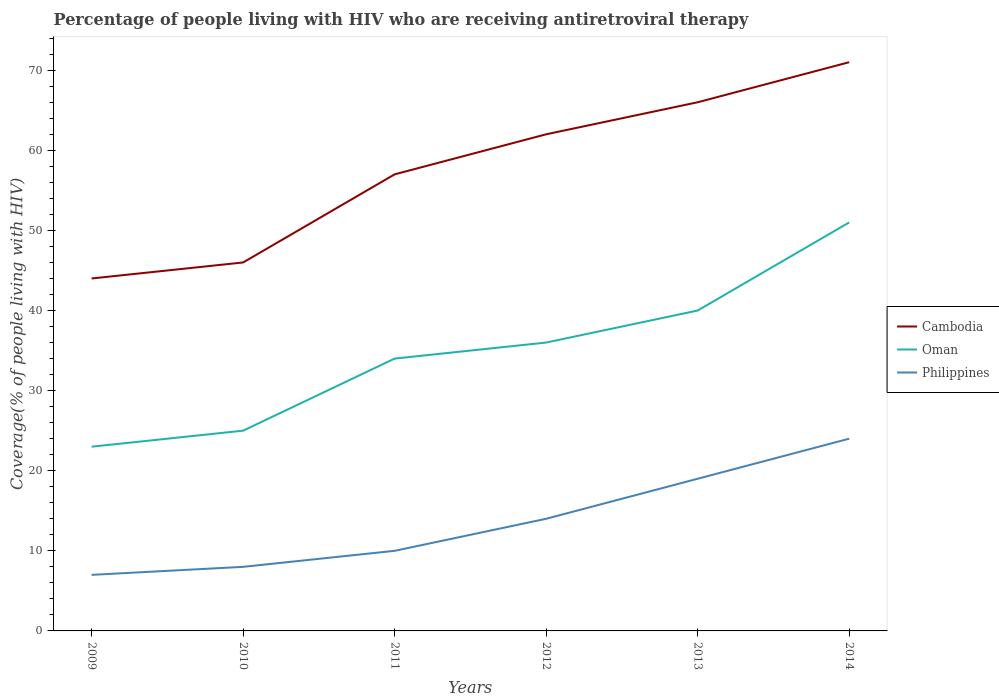How many different coloured lines are there?
Make the answer very short. 3. Does the line corresponding to Oman intersect with the line corresponding to Philippines?
Offer a terse response. No. Across all years, what is the maximum percentage of the HIV infected people who are receiving antiretroviral therapy in Philippines?
Make the answer very short. 7. What is the total percentage of the HIV infected people who are receiving antiretroviral therapy in Oman in the graph?
Make the answer very short. -17. What is the difference between the highest and the second highest percentage of the HIV infected people who are receiving antiretroviral therapy in Cambodia?
Offer a terse response. 27. Is the percentage of the HIV infected people who are receiving antiretroviral therapy in Philippines strictly greater than the percentage of the HIV infected people who are receiving antiretroviral therapy in Oman over the years?
Make the answer very short. Yes. How many years are there in the graph?
Keep it short and to the point. 6. Does the graph contain any zero values?
Your answer should be very brief. No. How many legend labels are there?
Provide a succinct answer. 3. How are the legend labels stacked?
Give a very brief answer. Vertical. What is the title of the graph?
Offer a terse response. Percentage of people living with HIV who are receiving antiretroviral therapy. What is the label or title of the X-axis?
Ensure brevity in your answer.  Years. What is the label or title of the Y-axis?
Offer a very short reply. Coverage(% of people living with HIV). What is the Coverage(% of people living with HIV) in Cambodia in 2009?
Give a very brief answer. 44. What is the Coverage(% of people living with HIV) in Oman in 2009?
Offer a terse response. 23. What is the Coverage(% of people living with HIV) of Philippines in 2010?
Offer a terse response. 8. What is the Coverage(% of people living with HIV) of Cambodia in 2011?
Keep it short and to the point. 57. What is the Coverage(% of people living with HIV) in Philippines in 2011?
Give a very brief answer. 10. What is the Coverage(% of people living with HIV) of Cambodia in 2013?
Offer a very short reply. 66. What is the Coverage(% of people living with HIV) of Philippines in 2013?
Give a very brief answer. 19. What is the Coverage(% of people living with HIV) in Cambodia in 2014?
Your answer should be compact. 71. Across all years, what is the maximum Coverage(% of people living with HIV) in Cambodia?
Keep it short and to the point. 71. Across all years, what is the maximum Coverage(% of people living with HIV) of Philippines?
Provide a short and direct response. 24. Across all years, what is the minimum Coverage(% of people living with HIV) in Philippines?
Your response must be concise. 7. What is the total Coverage(% of people living with HIV) in Cambodia in the graph?
Ensure brevity in your answer.  346. What is the total Coverage(% of people living with HIV) in Oman in the graph?
Provide a succinct answer. 209. What is the total Coverage(% of people living with HIV) of Philippines in the graph?
Your answer should be very brief. 82. What is the difference between the Coverage(% of people living with HIV) of Cambodia in 2009 and that in 2011?
Provide a succinct answer. -13. What is the difference between the Coverage(% of people living with HIV) in Oman in 2009 and that in 2011?
Provide a succinct answer. -11. What is the difference between the Coverage(% of people living with HIV) in Philippines in 2009 and that in 2011?
Offer a very short reply. -3. What is the difference between the Coverage(% of people living with HIV) of Philippines in 2009 and that in 2012?
Provide a short and direct response. -7. What is the difference between the Coverage(% of people living with HIV) in Cambodia in 2009 and that in 2013?
Offer a terse response. -22. What is the difference between the Coverage(% of people living with HIV) of Oman in 2009 and that in 2013?
Your answer should be very brief. -17. What is the difference between the Coverage(% of people living with HIV) in Philippines in 2009 and that in 2013?
Offer a terse response. -12. What is the difference between the Coverage(% of people living with HIV) of Oman in 2009 and that in 2014?
Provide a short and direct response. -28. What is the difference between the Coverage(% of people living with HIV) in Philippines in 2009 and that in 2014?
Provide a succinct answer. -17. What is the difference between the Coverage(% of people living with HIV) of Cambodia in 2010 and that in 2011?
Make the answer very short. -11. What is the difference between the Coverage(% of people living with HIV) of Oman in 2010 and that in 2011?
Give a very brief answer. -9. What is the difference between the Coverage(% of people living with HIV) in Philippines in 2010 and that in 2011?
Ensure brevity in your answer.  -2. What is the difference between the Coverage(% of people living with HIV) of Philippines in 2010 and that in 2012?
Your response must be concise. -6. What is the difference between the Coverage(% of people living with HIV) in Cambodia in 2010 and that in 2013?
Provide a short and direct response. -20. What is the difference between the Coverage(% of people living with HIV) of Oman in 2010 and that in 2013?
Offer a very short reply. -15. What is the difference between the Coverage(% of people living with HIV) of Philippines in 2010 and that in 2013?
Offer a very short reply. -11. What is the difference between the Coverage(% of people living with HIV) in Cambodia in 2010 and that in 2014?
Offer a very short reply. -25. What is the difference between the Coverage(% of people living with HIV) in Cambodia in 2011 and that in 2012?
Your answer should be compact. -5. What is the difference between the Coverage(% of people living with HIV) in Oman in 2011 and that in 2012?
Ensure brevity in your answer.  -2. What is the difference between the Coverage(% of people living with HIV) of Philippines in 2011 and that in 2012?
Make the answer very short. -4. What is the difference between the Coverage(% of people living with HIV) in Cambodia in 2011 and that in 2013?
Provide a succinct answer. -9. What is the difference between the Coverage(% of people living with HIV) in Oman in 2011 and that in 2013?
Offer a very short reply. -6. What is the difference between the Coverage(% of people living with HIV) of Philippines in 2011 and that in 2013?
Provide a succinct answer. -9. What is the difference between the Coverage(% of people living with HIV) of Oman in 2011 and that in 2014?
Your answer should be very brief. -17. What is the difference between the Coverage(% of people living with HIV) in Philippines in 2011 and that in 2014?
Your response must be concise. -14. What is the difference between the Coverage(% of people living with HIV) in Oman in 2012 and that in 2013?
Keep it short and to the point. -4. What is the difference between the Coverage(% of people living with HIV) in Oman in 2012 and that in 2014?
Offer a very short reply. -15. What is the difference between the Coverage(% of people living with HIV) of Oman in 2013 and that in 2014?
Your answer should be very brief. -11. What is the difference between the Coverage(% of people living with HIV) of Philippines in 2013 and that in 2014?
Provide a succinct answer. -5. What is the difference between the Coverage(% of people living with HIV) in Cambodia in 2009 and the Coverage(% of people living with HIV) in Oman in 2010?
Your response must be concise. 19. What is the difference between the Coverage(% of people living with HIV) of Oman in 2009 and the Coverage(% of people living with HIV) of Philippines in 2010?
Ensure brevity in your answer.  15. What is the difference between the Coverage(% of people living with HIV) of Cambodia in 2009 and the Coverage(% of people living with HIV) of Oman in 2011?
Offer a terse response. 10. What is the difference between the Coverage(% of people living with HIV) of Oman in 2009 and the Coverage(% of people living with HIV) of Philippines in 2011?
Offer a very short reply. 13. What is the difference between the Coverage(% of people living with HIV) in Cambodia in 2009 and the Coverage(% of people living with HIV) in Philippines in 2012?
Make the answer very short. 30. What is the difference between the Coverage(% of people living with HIV) in Oman in 2009 and the Coverage(% of people living with HIV) in Philippines in 2012?
Give a very brief answer. 9. What is the difference between the Coverage(% of people living with HIV) in Cambodia in 2009 and the Coverage(% of people living with HIV) in Oman in 2013?
Offer a very short reply. 4. What is the difference between the Coverage(% of people living with HIV) of Cambodia in 2009 and the Coverage(% of people living with HIV) of Philippines in 2013?
Keep it short and to the point. 25. What is the difference between the Coverage(% of people living with HIV) in Oman in 2009 and the Coverage(% of people living with HIV) in Philippines in 2014?
Provide a succinct answer. -1. What is the difference between the Coverage(% of people living with HIV) of Oman in 2010 and the Coverage(% of people living with HIV) of Philippines in 2011?
Ensure brevity in your answer.  15. What is the difference between the Coverage(% of people living with HIV) in Cambodia in 2010 and the Coverage(% of people living with HIV) in Oman in 2012?
Your answer should be compact. 10. What is the difference between the Coverage(% of people living with HIV) in Cambodia in 2010 and the Coverage(% of people living with HIV) in Philippines in 2012?
Your response must be concise. 32. What is the difference between the Coverage(% of people living with HIV) in Oman in 2010 and the Coverage(% of people living with HIV) in Philippines in 2012?
Offer a terse response. 11. What is the difference between the Coverage(% of people living with HIV) in Cambodia in 2010 and the Coverage(% of people living with HIV) in Philippines in 2013?
Ensure brevity in your answer.  27. What is the difference between the Coverage(% of people living with HIV) of Cambodia in 2010 and the Coverage(% of people living with HIV) of Oman in 2014?
Give a very brief answer. -5. What is the difference between the Coverage(% of people living with HIV) of Oman in 2010 and the Coverage(% of people living with HIV) of Philippines in 2014?
Your response must be concise. 1. What is the difference between the Coverage(% of people living with HIV) of Cambodia in 2011 and the Coverage(% of people living with HIV) of Oman in 2012?
Keep it short and to the point. 21. What is the difference between the Coverage(% of people living with HIV) of Cambodia in 2011 and the Coverage(% of people living with HIV) of Oman in 2013?
Provide a short and direct response. 17. What is the difference between the Coverage(% of people living with HIV) in Cambodia in 2011 and the Coverage(% of people living with HIV) in Philippines in 2013?
Keep it short and to the point. 38. What is the difference between the Coverage(% of people living with HIV) of Cambodia in 2011 and the Coverage(% of people living with HIV) of Oman in 2014?
Keep it short and to the point. 6. What is the difference between the Coverage(% of people living with HIV) of Cambodia in 2011 and the Coverage(% of people living with HIV) of Philippines in 2014?
Give a very brief answer. 33. What is the difference between the Coverage(% of people living with HIV) of Cambodia in 2012 and the Coverage(% of people living with HIV) of Oman in 2013?
Give a very brief answer. 22. What is the difference between the Coverage(% of people living with HIV) of Cambodia in 2012 and the Coverage(% of people living with HIV) of Philippines in 2013?
Your response must be concise. 43. What is the difference between the Coverage(% of people living with HIV) in Oman in 2012 and the Coverage(% of people living with HIV) in Philippines in 2013?
Your answer should be very brief. 17. What is the difference between the Coverage(% of people living with HIV) in Cambodia in 2012 and the Coverage(% of people living with HIV) in Oman in 2014?
Ensure brevity in your answer.  11. What is the difference between the Coverage(% of people living with HIV) of Oman in 2012 and the Coverage(% of people living with HIV) of Philippines in 2014?
Provide a short and direct response. 12. What is the difference between the Coverage(% of people living with HIV) in Cambodia in 2013 and the Coverage(% of people living with HIV) in Philippines in 2014?
Keep it short and to the point. 42. What is the difference between the Coverage(% of people living with HIV) in Oman in 2013 and the Coverage(% of people living with HIV) in Philippines in 2014?
Your answer should be very brief. 16. What is the average Coverage(% of people living with HIV) in Cambodia per year?
Provide a short and direct response. 57.67. What is the average Coverage(% of people living with HIV) in Oman per year?
Provide a short and direct response. 34.83. What is the average Coverage(% of people living with HIV) in Philippines per year?
Provide a short and direct response. 13.67. In the year 2010, what is the difference between the Coverage(% of people living with HIV) in Cambodia and Coverage(% of people living with HIV) in Oman?
Give a very brief answer. 21. In the year 2010, what is the difference between the Coverage(% of people living with HIV) of Oman and Coverage(% of people living with HIV) of Philippines?
Ensure brevity in your answer.  17. In the year 2011, what is the difference between the Coverage(% of people living with HIV) in Oman and Coverage(% of people living with HIV) in Philippines?
Your answer should be compact. 24. In the year 2013, what is the difference between the Coverage(% of people living with HIV) in Cambodia and Coverage(% of people living with HIV) in Oman?
Give a very brief answer. 26. In the year 2013, what is the difference between the Coverage(% of people living with HIV) in Cambodia and Coverage(% of people living with HIV) in Philippines?
Your answer should be very brief. 47. In the year 2014, what is the difference between the Coverage(% of people living with HIV) of Cambodia and Coverage(% of people living with HIV) of Philippines?
Your answer should be compact. 47. In the year 2014, what is the difference between the Coverage(% of people living with HIV) in Oman and Coverage(% of people living with HIV) in Philippines?
Make the answer very short. 27. What is the ratio of the Coverage(% of people living with HIV) of Cambodia in 2009 to that in 2010?
Your response must be concise. 0.96. What is the ratio of the Coverage(% of people living with HIV) of Philippines in 2009 to that in 2010?
Your answer should be very brief. 0.88. What is the ratio of the Coverage(% of people living with HIV) of Cambodia in 2009 to that in 2011?
Give a very brief answer. 0.77. What is the ratio of the Coverage(% of people living with HIV) of Oman in 2009 to that in 2011?
Keep it short and to the point. 0.68. What is the ratio of the Coverage(% of people living with HIV) in Cambodia in 2009 to that in 2012?
Your answer should be very brief. 0.71. What is the ratio of the Coverage(% of people living with HIV) in Oman in 2009 to that in 2012?
Your response must be concise. 0.64. What is the ratio of the Coverage(% of people living with HIV) of Philippines in 2009 to that in 2012?
Your response must be concise. 0.5. What is the ratio of the Coverage(% of people living with HIV) of Oman in 2009 to that in 2013?
Provide a succinct answer. 0.57. What is the ratio of the Coverage(% of people living with HIV) in Philippines in 2009 to that in 2013?
Offer a terse response. 0.37. What is the ratio of the Coverage(% of people living with HIV) in Cambodia in 2009 to that in 2014?
Ensure brevity in your answer.  0.62. What is the ratio of the Coverage(% of people living with HIV) in Oman in 2009 to that in 2014?
Keep it short and to the point. 0.45. What is the ratio of the Coverage(% of people living with HIV) in Philippines in 2009 to that in 2014?
Your answer should be compact. 0.29. What is the ratio of the Coverage(% of people living with HIV) in Cambodia in 2010 to that in 2011?
Provide a succinct answer. 0.81. What is the ratio of the Coverage(% of people living with HIV) in Oman in 2010 to that in 2011?
Keep it short and to the point. 0.74. What is the ratio of the Coverage(% of people living with HIV) in Philippines in 2010 to that in 2011?
Your answer should be compact. 0.8. What is the ratio of the Coverage(% of people living with HIV) of Cambodia in 2010 to that in 2012?
Give a very brief answer. 0.74. What is the ratio of the Coverage(% of people living with HIV) in Oman in 2010 to that in 2012?
Your answer should be very brief. 0.69. What is the ratio of the Coverage(% of people living with HIV) of Philippines in 2010 to that in 2012?
Make the answer very short. 0.57. What is the ratio of the Coverage(% of people living with HIV) of Cambodia in 2010 to that in 2013?
Keep it short and to the point. 0.7. What is the ratio of the Coverage(% of people living with HIV) in Philippines in 2010 to that in 2013?
Keep it short and to the point. 0.42. What is the ratio of the Coverage(% of people living with HIV) of Cambodia in 2010 to that in 2014?
Provide a succinct answer. 0.65. What is the ratio of the Coverage(% of people living with HIV) in Oman in 2010 to that in 2014?
Your response must be concise. 0.49. What is the ratio of the Coverage(% of people living with HIV) of Cambodia in 2011 to that in 2012?
Offer a terse response. 0.92. What is the ratio of the Coverage(% of people living with HIV) in Oman in 2011 to that in 2012?
Offer a terse response. 0.94. What is the ratio of the Coverage(% of people living with HIV) in Cambodia in 2011 to that in 2013?
Provide a succinct answer. 0.86. What is the ratio of the Coverage(% of people living with HIV) in Philippines in 2011 to that in 2013?
Provide a short and direct response. 0.53. What is the ratio of the Coverage(% of people living with HIV) in Cambodia in 2011 to that in 2014?
Give a very brief answer. 0.8. What is the ratio of the Coverage(% of people living with HIV) in Philippines in 2011 to that in 2014?
Make the answer very short. 0.42. What is the ratio of the Coverage(% of people living with HIV) of Cambodia in 2012 to that in 2013?
Provide a short and direct response. 0.94. What is the ratio of the Coverage(% of people living with HIV) in Philippines in 2012 to that in 2013?
Your response must be concise. 0.74. What is the ratio of the Coverage(% of people living with HIV) in Cambodia in 2012 to that in 2014?
Keep it short and to the point. 0.87. What is the ratio of the Coverage(% of people living with HIV) of Oman in 2012 to that in 2014?
Your response must be concise. 0.71. What is the ratio of the Coverage(% of people living with HIV) in Philippines in 2012 to that in 2014?
Provide a succinct answer. 0.58. What is the ratio of the Coverage(% of people living with HIV) in Cambodia in 2013 to that in 2014?
Offer a very short reply. 0.93. What is the ratio of the Coverage(% of people living with HIV) of Oman in 2013 to that in 2014?
Keep it short and to the point. 0.78. What is the ratio of the Coverage(% of people living with HIV) in Philippines in 2013 to that in 2014?
Make the answer very short. 0.79. What is the difference between the highest and the second highest Coverage(% of people living with HIV) in Cambodia?
Give a very brief answer. 5. What is the difference between the highest and the second highest Coverage(% of people living with HIV) in Philippines?
Your answer should be compact. 5. What is the difference between the highest and the lowest Coverage(% of people living with HIV) of Cambodia?
Make the answer very short. 27. What is the difference between the highest and the lowest Coverage(% of people living with HIV) in Oman?
Make the answer very short. 28. What is the difference between the highest and the lowest Coverage(% of people living with HIV) of Philippines?
Offer a very short reply. 17. 